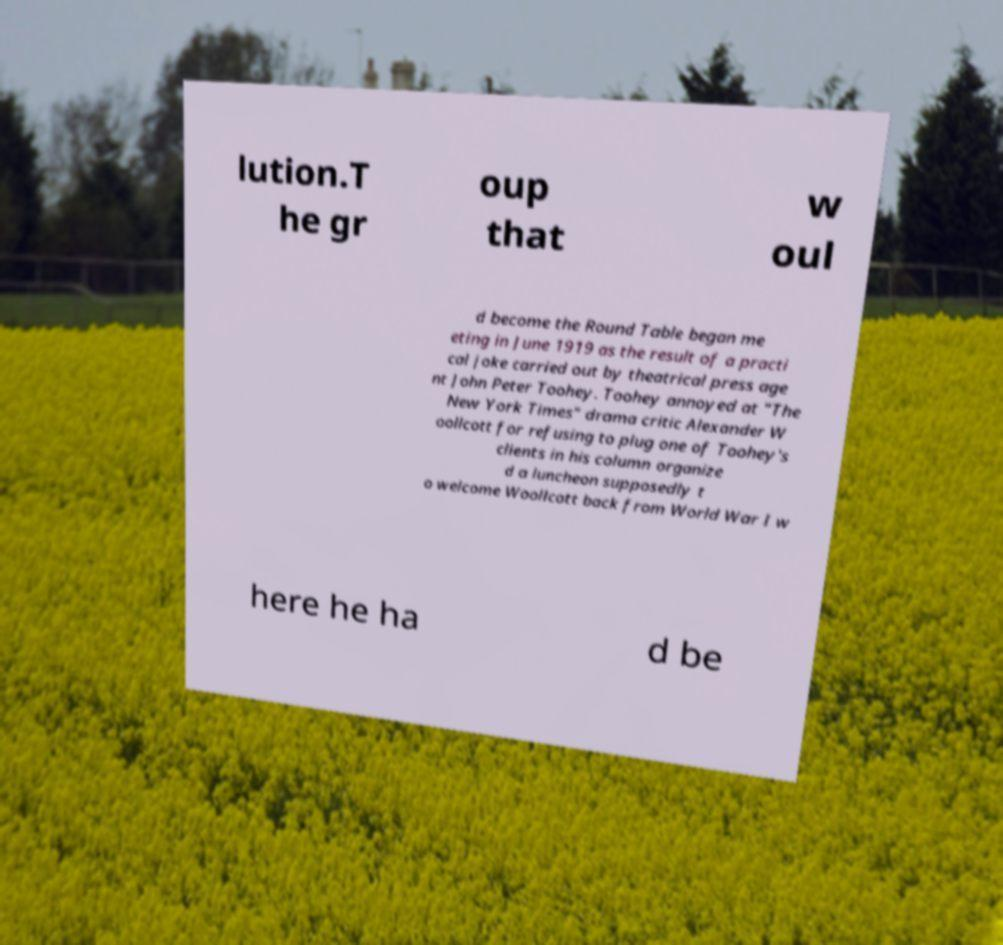Could you extract and type out the text from this image? lution.T he gr oup that w oul d become the Round Table began me eting in June 1919 as the result of a practi cal joke carried out by theatrical press age nt John Peter Toohey. Toohey annoyed at "The New York Times" drama critic Alexander W oollcott for refusing to plug one of Toohey's clients in his column organize d a luncheon supposedly t o welcome Woollcott back from World War I w here he ha d be 